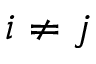<formula> <loc_0><loc_0><loc_500><loc_500>i \neq j</formula> 